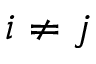<formula> <loc_0><loc_0><loc_500><loc_500>i \neq j</formula> 